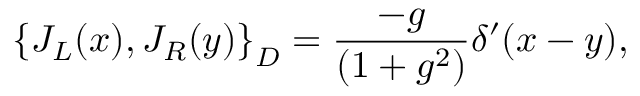Convert formula to latex. <formula><loc_0><loc_0><loc_500><loc_500>\left \{ J _ { L } ( x ) , J _ { R } ( y ) \right \} _ { D } = \frac { - g } { ( 1 + g ^ { 2 } ) } \delta ^ { \prime } ( x - y ) ,</formula> 